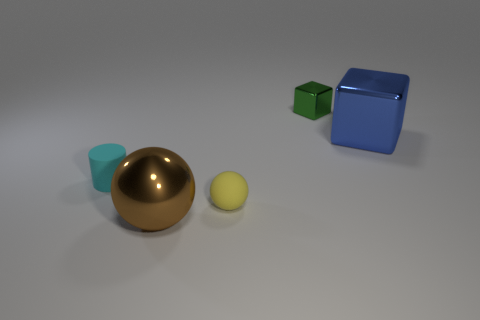Is there anything else that is the same size as the cyan object?
Provide a short and direct response. Yes. What number of things are both behind the cyan rubber object and on the left side of the blue object?
Ensure brevity in your answer.  1. What color is the large metallic object behind the ball left of the small thing that is in front of the cyan matte cylinder?
Provide a short and direct response. Blue. There is a block that is left of the blue metal thing; what number of green metal things are to the right of it?
Give a very brief answer. 0. What number of other objects are there of the same shape as the blue thing?
Make the answer very short. 1. What number of objects are either small green metal cubes or large things in front of the blue metal thing?
Ensure brevity in your answer.  2. Are there more cyan matte things that are in front of the cyan thing than tiny green things that are in front of the big brown ball?
Your answer should be compact. No. What is the shape of the tiny thing that is in front of the small matte object behind the matte object that is in front of the small cyan matte thing?
Provide a short and direct response. Sphere. There is a large metal thing to the right of the large object in front of the blue block; what is its shape?
Provide a short and direct response. Cube. Is there a cylinder made of the same material as the large brown thing?
Provide a short and direct response. No. 